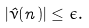<formula> <loc_0><loc_0><loc_500><loc_500>| \hat { \nu } ( n ) | \leq \epsilon .</formula> 